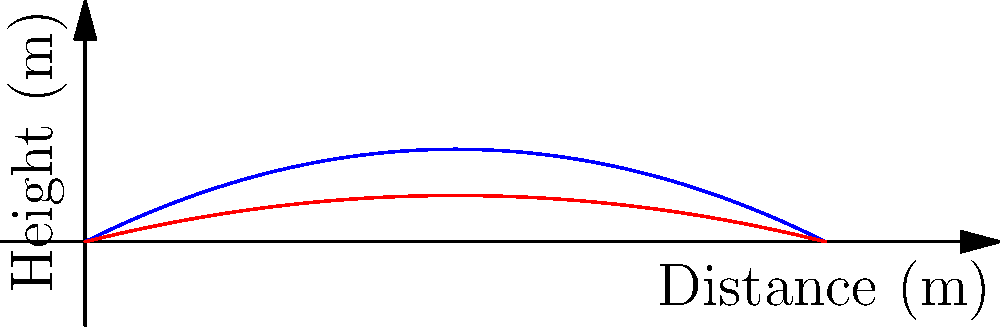As a sports blogger, you're analyzing the trajectory of footballs thrown at different angles. The graph shows two parabolic paths: one for a football thrown at a 45° angle (blue) and another at a 30° angle (red). Both are thrown with the same initial velocity. Which throw travels farther horizontally, and by approximately how many meters? To determine which throw travels farther horizontally and by how much, we need to analyze the x-intercepts of both trajectories:

1. The x-intercept represents the horizontal distance traveled by the football.
2. For the 45° throw (blue curve):
   - The x-intercept is approximately at x = 7.5 m
3. For the 30° throw (red curve):
   - The x-intercept is at x = 10 m
4. To find the difference:
   $10 m - 7.5 m = 2.5 m$

The 30° throw travels farther horizontally than the 45° throw by approximately 2.5 meters.

This result aligns with projectile motion theory:
- A 45° angle maximizes height but not horizontal distance.
- A lower angle (like 30°) sacrifices height for increased horizontal distance.
- The optimal angle for maximum range is slightly below 45° due to air resistance, typically around 40-43°.
Answer: The 30° throw travels 2.5 m farther. 